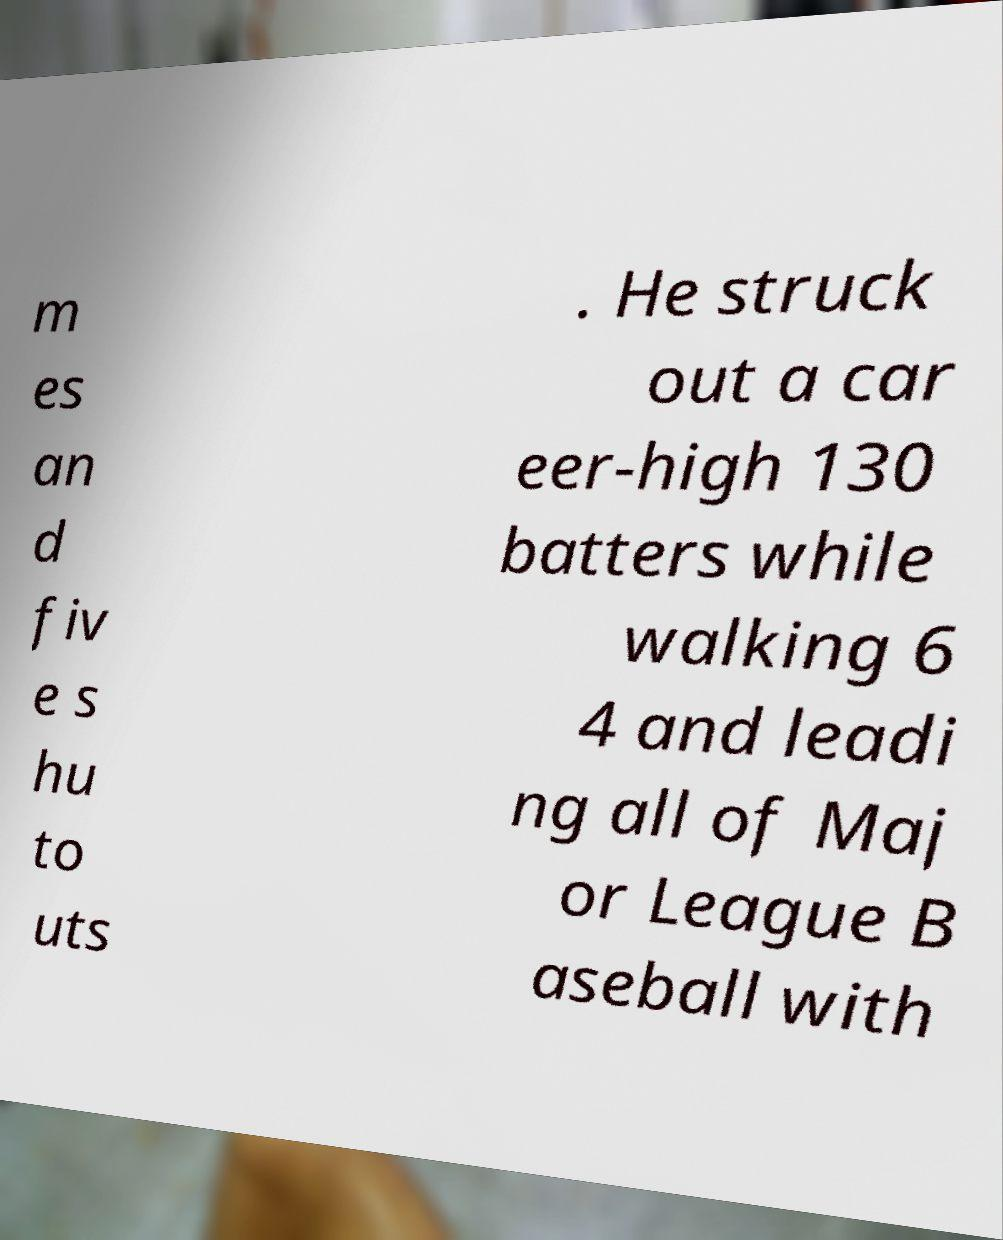Can you read and provide the text displayed in the image?This photo seems to have some interesting text. Can you extract and type it out for me? m es an d fiv e s hu to uts . He struck out a car eer-high 130 batters while walking 6 4 and leadi ng all of Maj or League B aseball with 